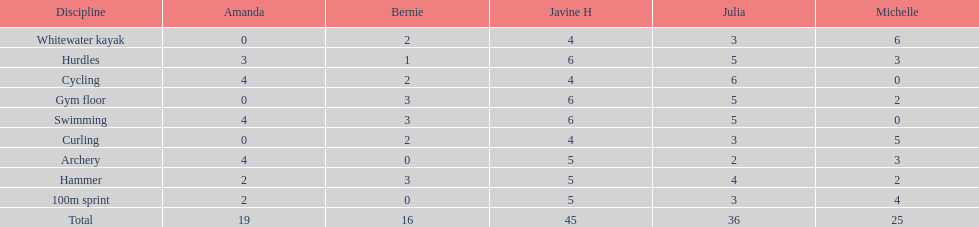What is the usual score for a 100m race? 2.8. 